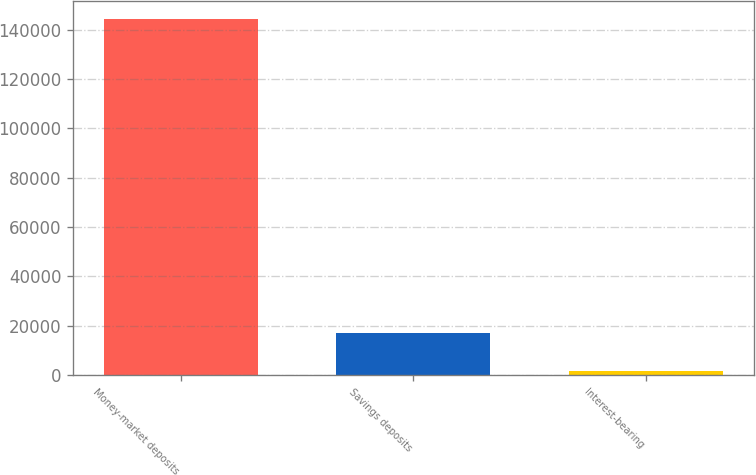Convert chart to OTSL. <chart><loc_0><loc_0><loc_500><loc_500><bar_chart><fcel>Money-market deposits<fcel>Savings deposits<fcel>Interest-bearing<nl><fcel>144617<fcel>16943<fcel>1728<nl></chart> 